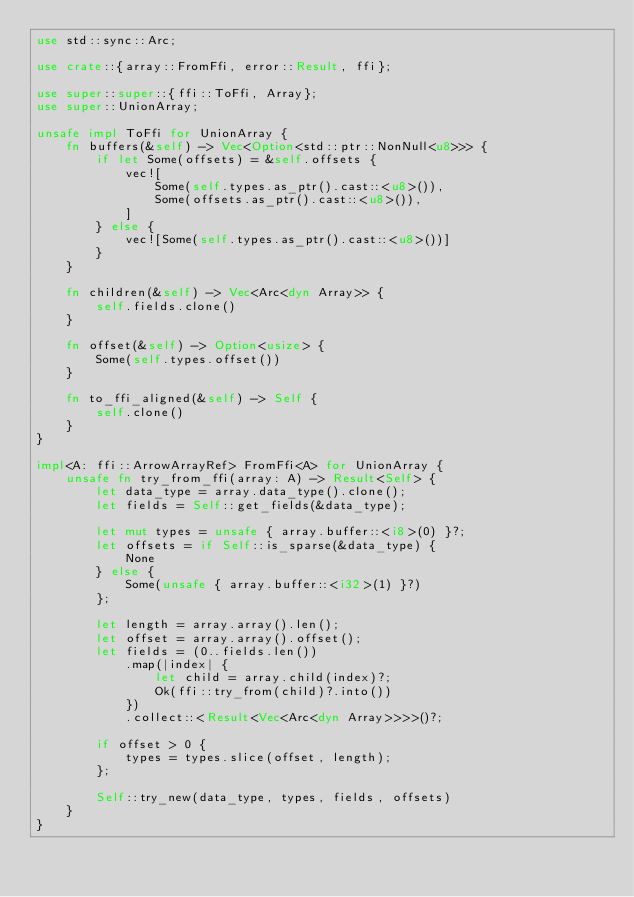<code> <loc_0><loc_0><loc_500><loc_500><_Rust_>use std::sync::Arc;

use crate::{array::FromFfi, error::Result, ffi};

use super::super::{ffi::ToFfi, Array};
use super::UnionArray;

unsafe impl ToFfi for UnionArray {
    fn buffers(&self) -> Vec<Option<std::ptr::NonNull<u8>>> {
        if let Some(offsets) = &self.offsets {
            vec![
                Some(self.types.as_ptr().cast::<u8>()),
                Some(offsets.as_ptr().cast::<u8>()),
            ]
        } else {
            vec![Some(self.types.as_ptr().cast::<u8>())]
        }
    }

    fn children(&self) -> Vec<Arc<dyn Array>> {
        self.fields.clone()
    }

    fn offset(&self) -> Option<usize> {
        Some(self.types.offset())
    }

    fn to_ffi_aligned(&self) -> Self {
        self.clone()
    }
}

impl<A: ffi::ArrowArrayRef> FromFfi<A> for UnionArray {
    unsafe fn try_from_ffi(array: A) -> Result<Self> {
        let data_type = array.data_type().clone();
        let fields = Self::get_fields(&data_type);

        let mut types = unsafe { array.buffer::<i8>(0) }?;
        let offsets = if Self::is_sparse(&data_type) {
            None
        } else {
            Some(unsafe { array.buffer::<i32>(1) }?)
        };

        let length = array.array().len();
        let offset = array.array().offset();
        let fields = (0..fields.len())
            .map(|index| {
                let child = array.child(index)?;
                Ok(ffi::try_from(child)?.into())
            })
            .collect::<Result<Vec<Arc<dyn Array>>>>()?;

        if offset > 0 {
            types = types.slice(offset, length);
        };

        Self::try_new(data_type, types, fields, offsets)
    }
}
</code> 